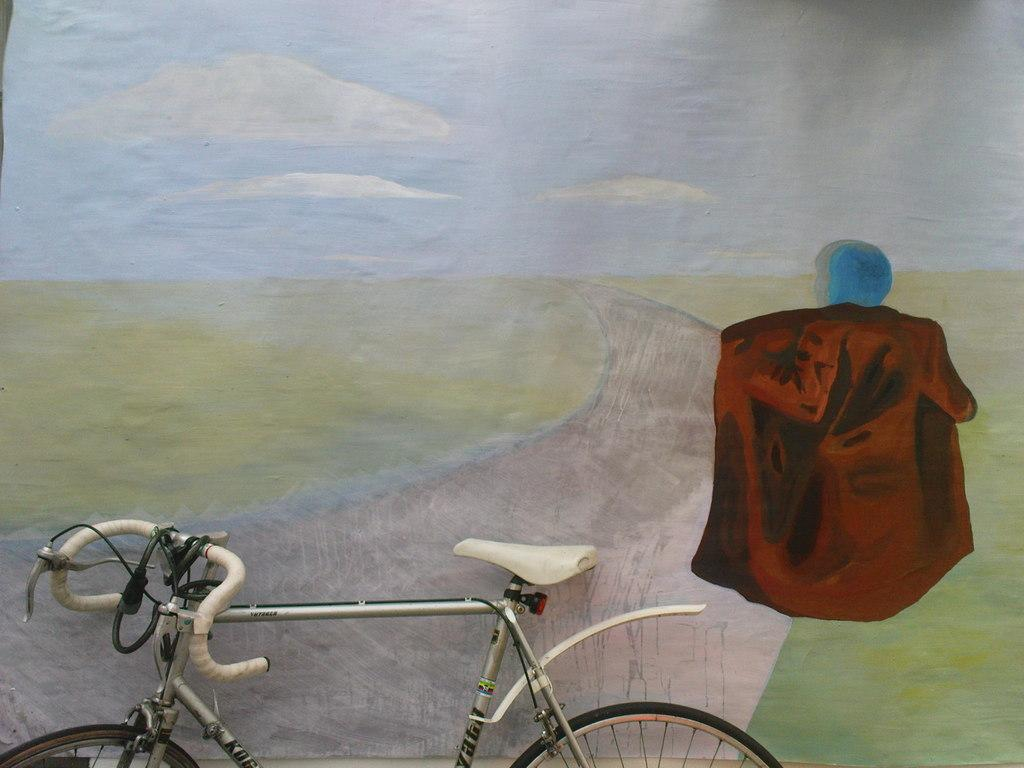What is the main subject of the picture? The main subject of the picture is a bicycle. What can be seen in the background of the picture? There is a wall in the background of the picture. What is on the wall? There is a painting on the wall. What does the painting depict? The painting depicts a sky, a road, and a person. What is the income of the writer depicted in the painting? There is no writer depicted in the painting, and therefore no income can be determined. 